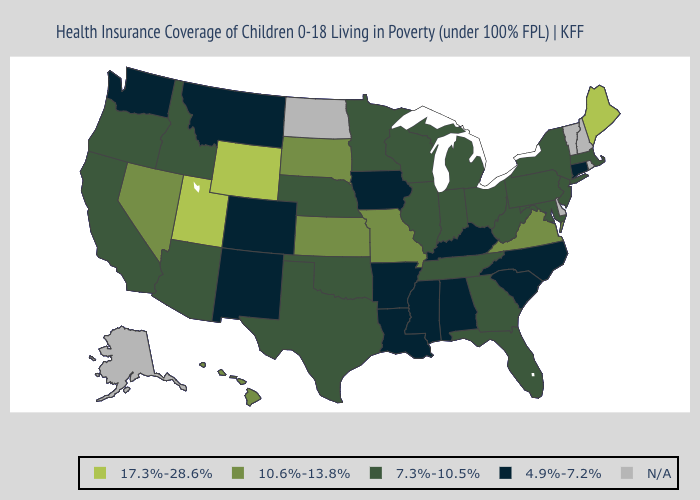What is the value of Minnesota?
Answer briefly. 7.3%-10.5%. What is the value of North Dakota?
Short answer required. N/A. Name the states that have a value in the range N/A?
Be succinct. Alaska, Delaware, New Hampshire, North Dakota, Rhode Island, Vermont. What is the value of Nebraska?
Keep it brief. 7.3%-10.5%. Name the states that have a value in the range 7.3%-10.5%?
Keep it brief. Arizona, California, Florida, Georgia, Idaho, Illinois, Indiana, Maryland, Massachusetts, Michigan, Minnesota, Nebraska, New Jersey, New York, Ohio, Oklahoma, Oregon, Pennsylvania, Tennessee, Texas, West Virginia, Wisconsin. What is the lowest value in the USA?
Keep it brief. 4.9%-7.2%. What is the highest value in states that border North Carolina?
Give a very brief answer. 10.6%-13.8%. Name the states that have a value in the range N/A?
Keep it brief. Alaska, Delaware, New Hampshire, North Dakota, Rhode Island, Vermont. Which states hav the highest value in the South?
Give a very brief answer. Virginia. Name the states that have a value in the range 4.9%-7.2%?
Concise answer only. Alabama, Arkansas, Colorado, Connecticut, Iowa, Kentucky, Louisiana, Mississippi, Montana, New Mexico, North Carolina, South Carolina, Washington. How many symbols are there in the legend?
Be succinct. 5. Does the first symbol in the legend represent the smallest category?
Give a very brief answer. No. Which states have the lowest value in the South?
Answer briefly. Alabama, Arkansas, Kentucky, Louisiana, Mississippi, North Carolina, South Carolina. 